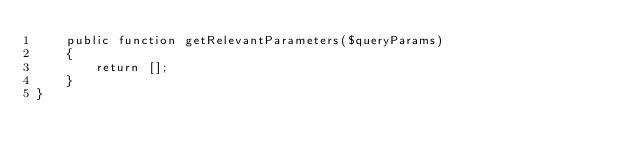Convert code to text. <code><loc_0><loc_0><loc_500><loc_500><_PHP_>    public function getRelevantParameters($queryParams)
    {
        return [];
    }
}
</code> 